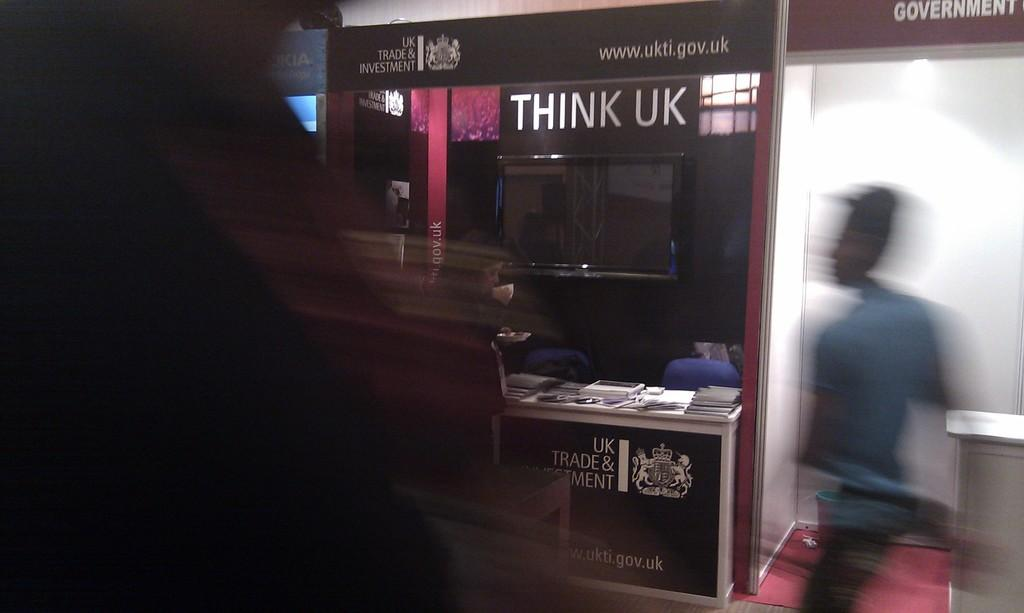<image>
Write a terse but informative summary of the picture. A blurred picture of a person with a sign saying Think UK 